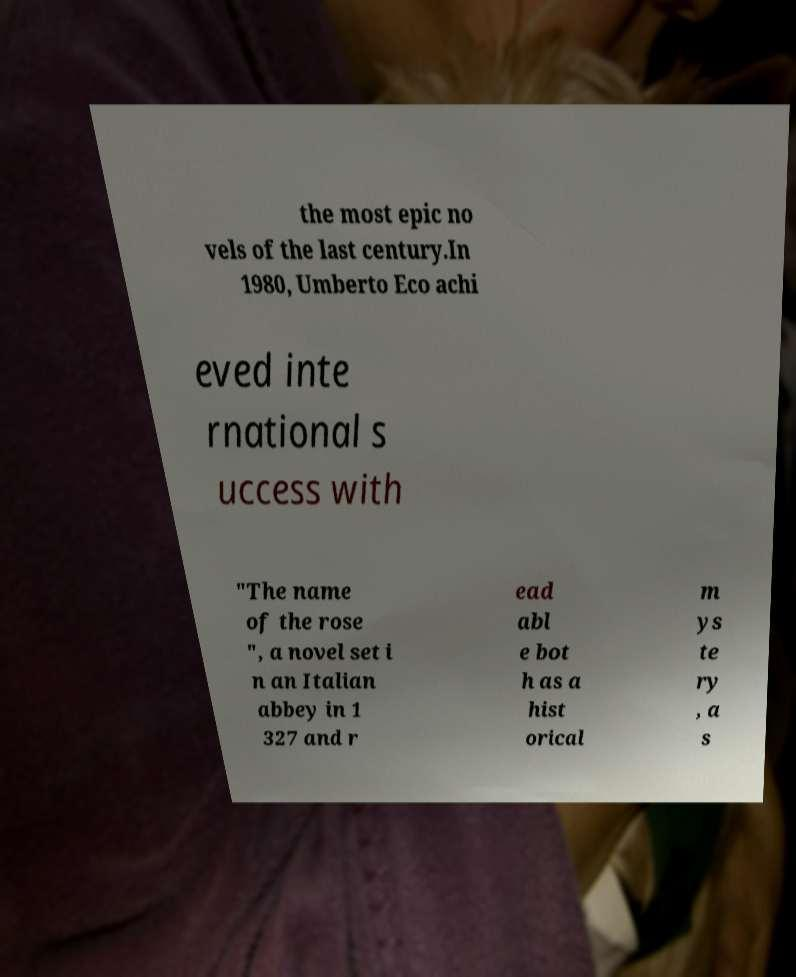Please read and relay the text visible in this image. What does it say? the most epic no vels of the last century.In 1980, Umberto Eco achi eved inte rnational s uccess with "The name of the rose ", a novel set i n an Italian abbey in 1 327 and r ead abl e bot h as a hist orical m ys te ry , a s 